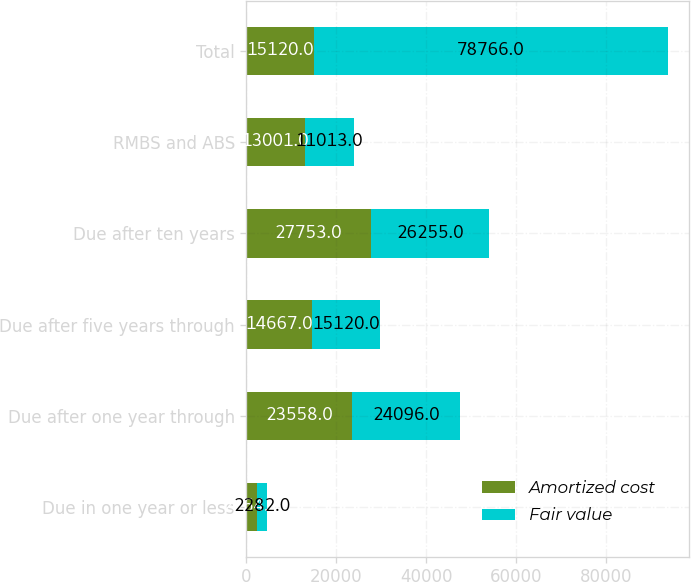<chart> <loc_0><loc_0><loc_500><loc_500><stacked_bar_chart><ecel><fcel>Due in one year or less<fcel>Due after one year through<fcel>Due after five years through<fcel>Due after ten years<fcel>RMBS and ABS<fcel>Total<nl><fcel>Amortized cost<fcel>2264<fcel>23558<fcel>14667<fcel>27753<fcel>13001<fcel>15120<nl><fcel>Fair value<fcel>2282<fcel>24096<fcel>15120<fcel>26255<fcel>11013<fcel>78766<nl></chart> 